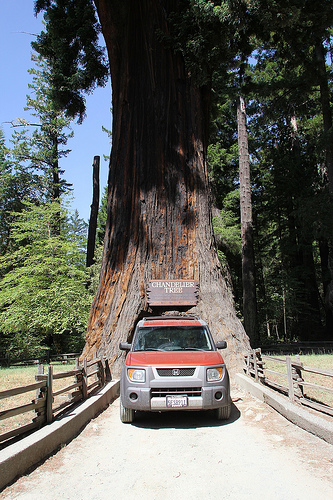<image>
Is there a car to the right of the tree? No. The car is not to the right of the tree. The horizontal positioning shows a different relationship. 